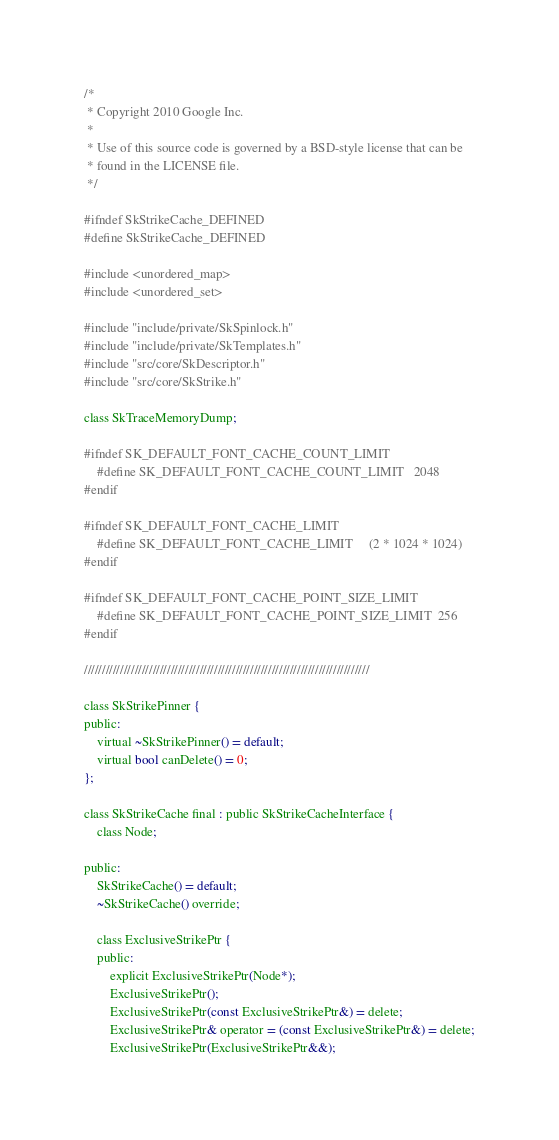Convert code to text. <code><loc_0><loc_0><loc_500><loc_500><_C_>/*
 * Copyright 2010 Google Inc.
 *
 * Use of this source code is governed by a BSD-style license that can be
 * found in the LICENSE file.
 */

#ifndef SkStrikeCache_DEFINED
#define SkStrikeCache_DEFINED

#include <unordered_map>
#include <unordered_set>

#include "include/private/SkSpinlock.h"
#include "include/private/SkTemplates.h"
#include "src/core/SkDescriptor.h"
#include "src/core/SkStrike.h"

class SkTraceMemoryDump;

#ifndef SK_DEFAULT_FONT_CACHE_COUNT_LIMIT
    #define SK_DEFAULT_FONT_CACHE_COUNT_LIMIT   2048
#endif

#ifndef SK_DEFAULT_FONT_CACHE_LIMIT
    #define SK_DEFAULT_FONT_CACHE_LIMIT     (2 * 1024 * 1024)
#endif

#ifndef SK_DEFAULT_FONT_CACHE_POINT_SIZE_LIMIT
    #define SK_DEFAULT_FONT_CACHE_POINT_SIZE_LIMIT  256
#endif

///////////////////////////////////////////////////////////////////////////////

class SkStrikePinner {
public:
    virtual ~SkStrikePinner() = default;
    virtual bool canDelete() = 0;
};

class SkStrikeCache final : public SkStrikeCacheInterface {
    class Node;

public:
    SkStrikeCache() = default;
    ~SkStrikeCache() override;

    class ExclusiveStrikePtr {
    public:
        explicit ExclusiveStrikePtr(Node*);
        ExclusiveStrikePtr();
        ExclusiveStrikePtr(const ExclusiveStrikePtr&) = delete;
        ExclusiveStrikePtr& operator = (const ExclusiveStrikePtr&) = delete;
        ExclusiveStrikePtr(ExclusiveStrikePtr&&);</code> 